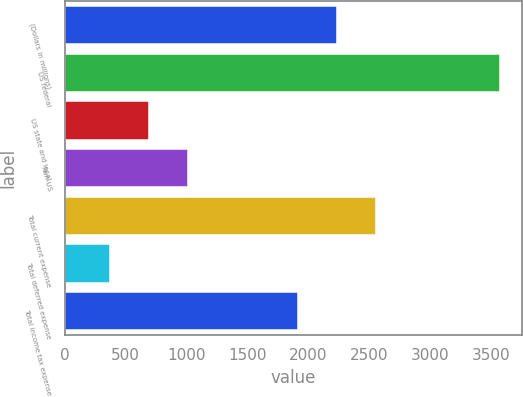<chart> <loc_0><loc_0><loc_500><loc_500><bar_chart><fcel>(Dollars in millions)<fcel>US federal<fcel>US state and local<fcel>Non-US<fcel>Total current expense<fcel>Total deferred expense<fcel>Total income tax expense<nl><fcel>2236.6<fcel>3576<fcel>690.6<fcel>1011.2<fcel>2557.2<fcel>370<fcel>1916<nl></chart> 